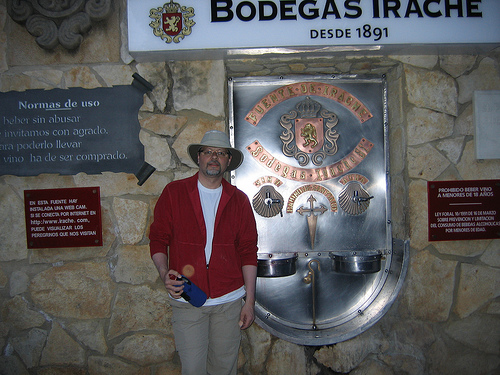<image>
Is the badge next to the wall? No. The badge is not positioned next to the wall. They are located in different areas of the scene. 